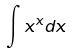Convert formula to latex. <formula><loc_0><loc_0><loc_500><loc_500>\int x ^ { x } d x</formula> 